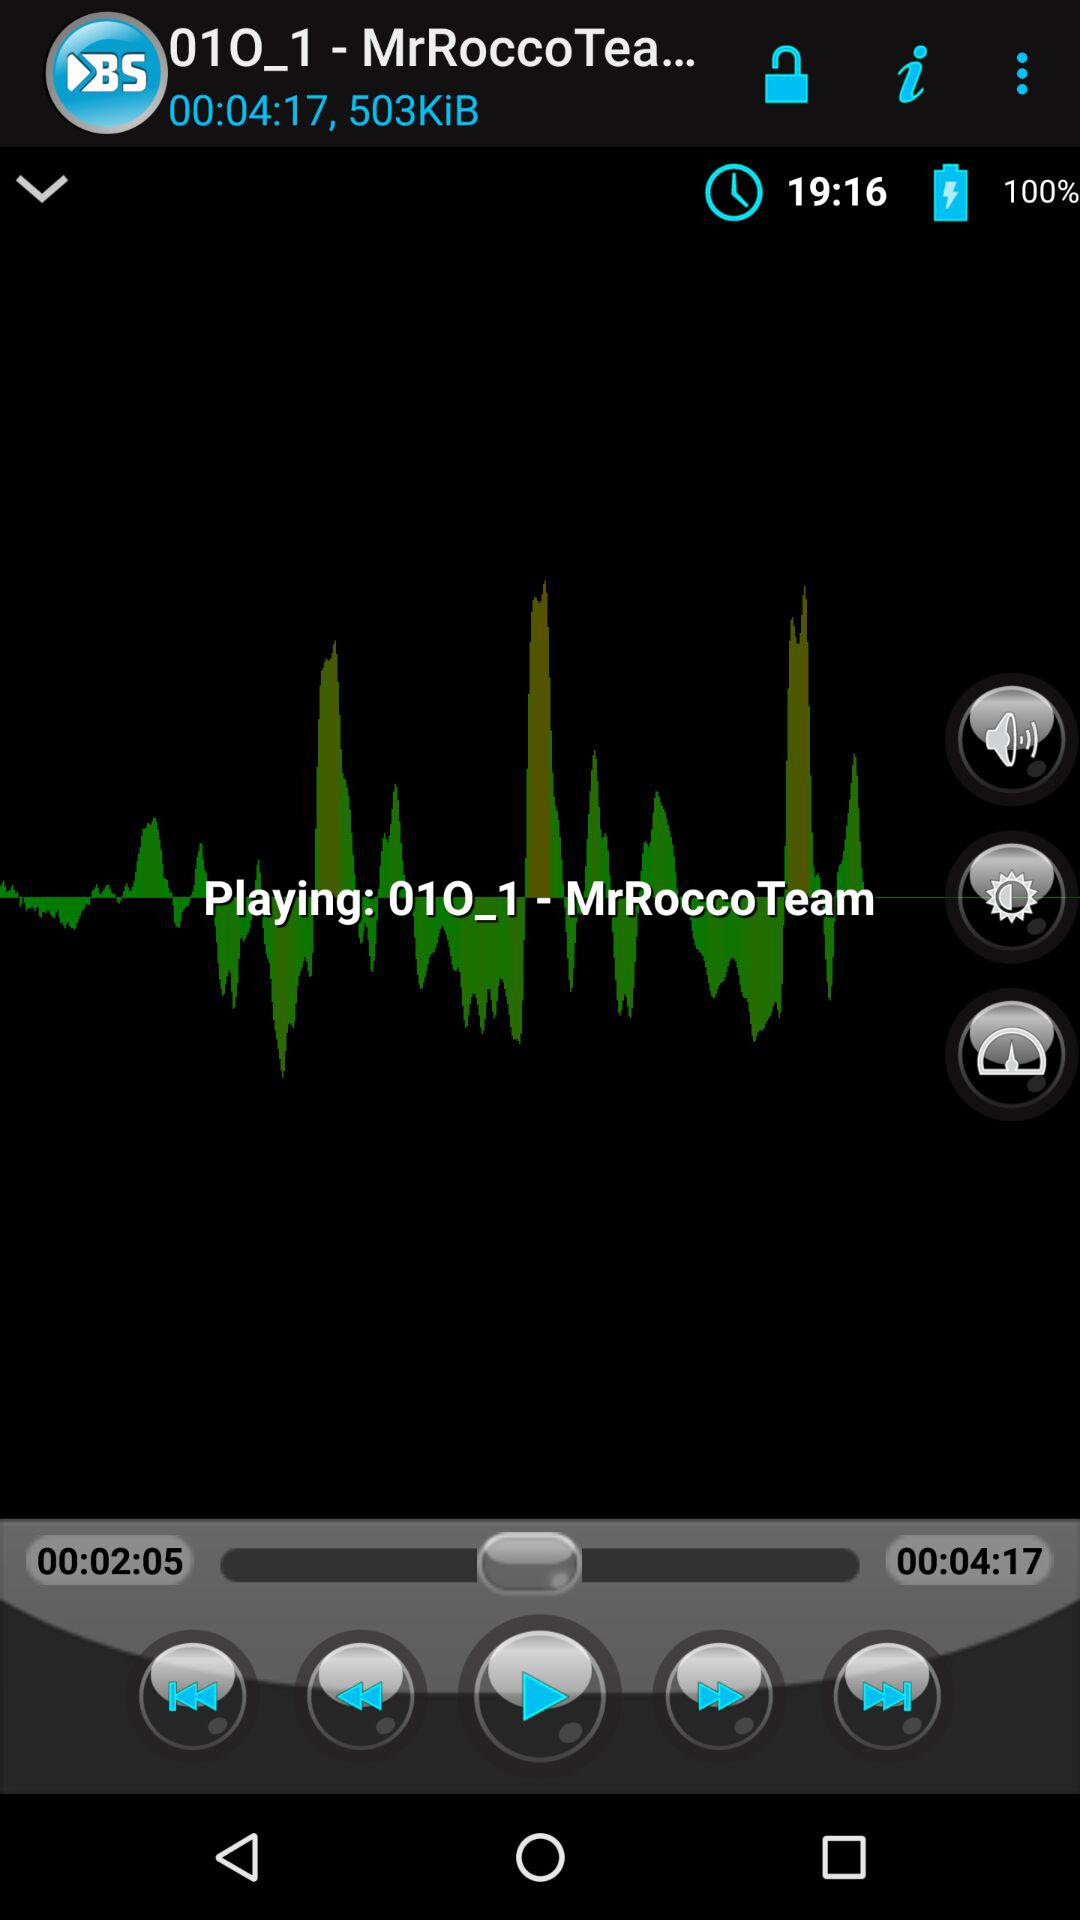Which audio is currently playing? The audio currently playing is "01O_1". 